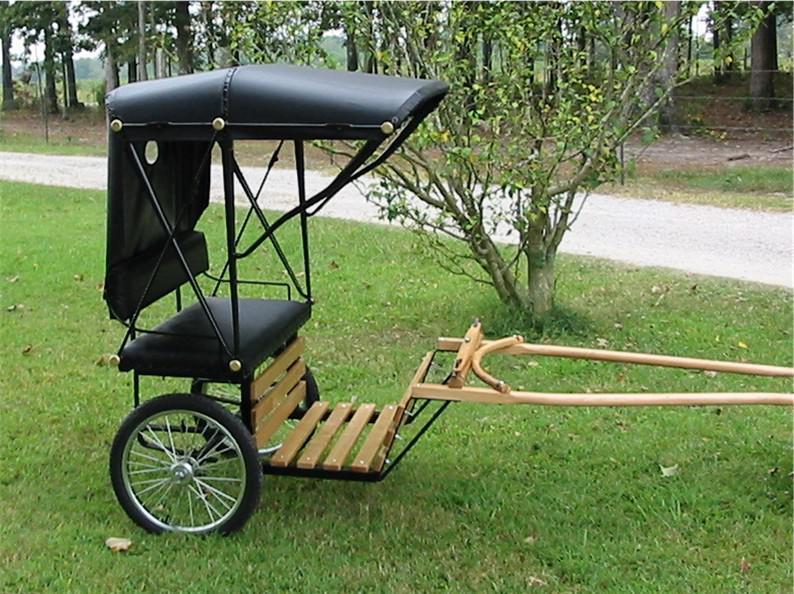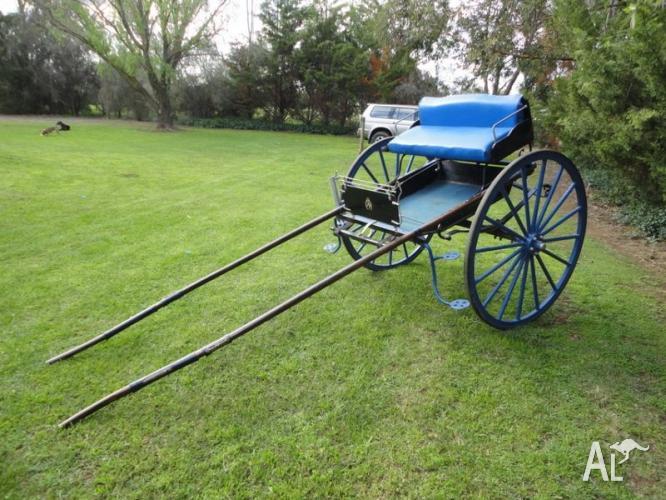The first image is the image on the left, the second image is the image on the right. Considering the images on both sides, is "There are two carts, but only one of them has a canopy." valid? Answer yes or no. Yes. The first image is the image on the left, the second image is the image on the right. Considering the images on both sides, is "An image shows a four-wheeled buggy with a canopy over an upholstered seat." valid? Answer yes or no. No. 